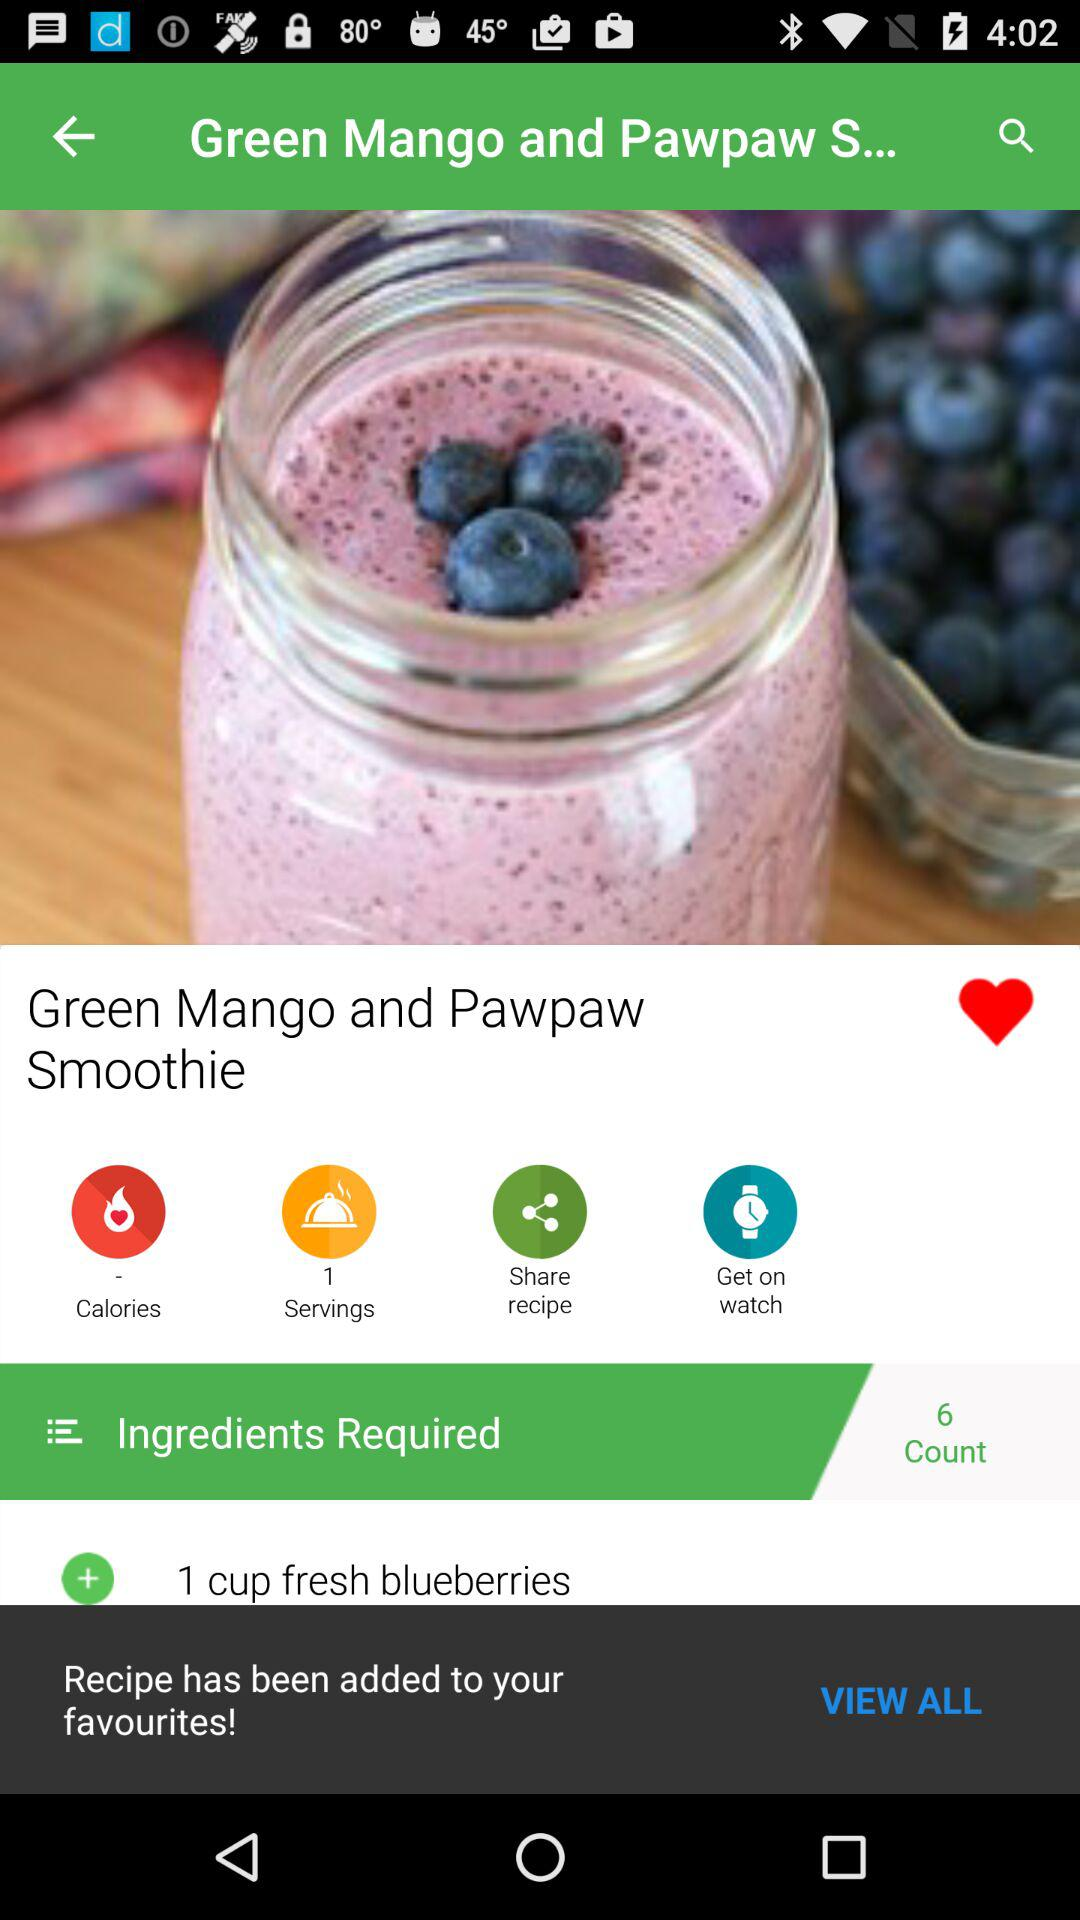What is the name of the recipe? The name of the recipe is "Green Mango and Pawpaw Smoothie". 